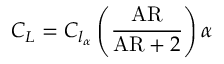Convert formula to latex. <formula><loc_0><loc_0><loc_500><loc_500>\ C _ { L } = C _ { l _ { \alpha } } \left ( { \frac { A R } { { A R } + 2 } } \right ) \alpha</formula> 